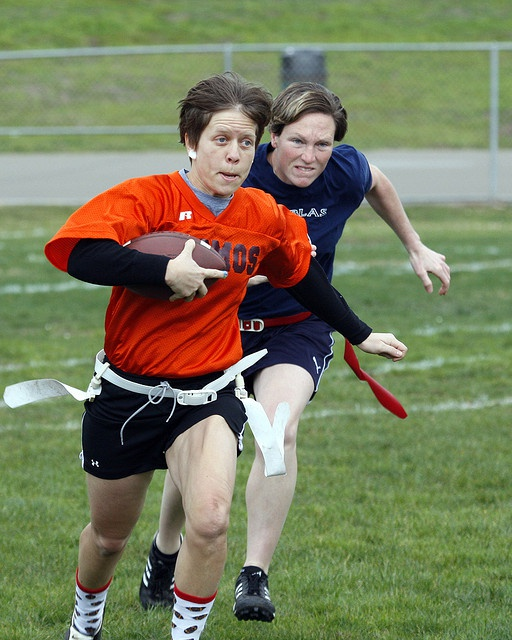Describe the objects in this image and their specific colors. I can see people in olive, black, red, lightgray, and maroon tones, people in olive, black, darkgray, lightgray, and navy tones, and sports ball in olive and gray tones in this image. 